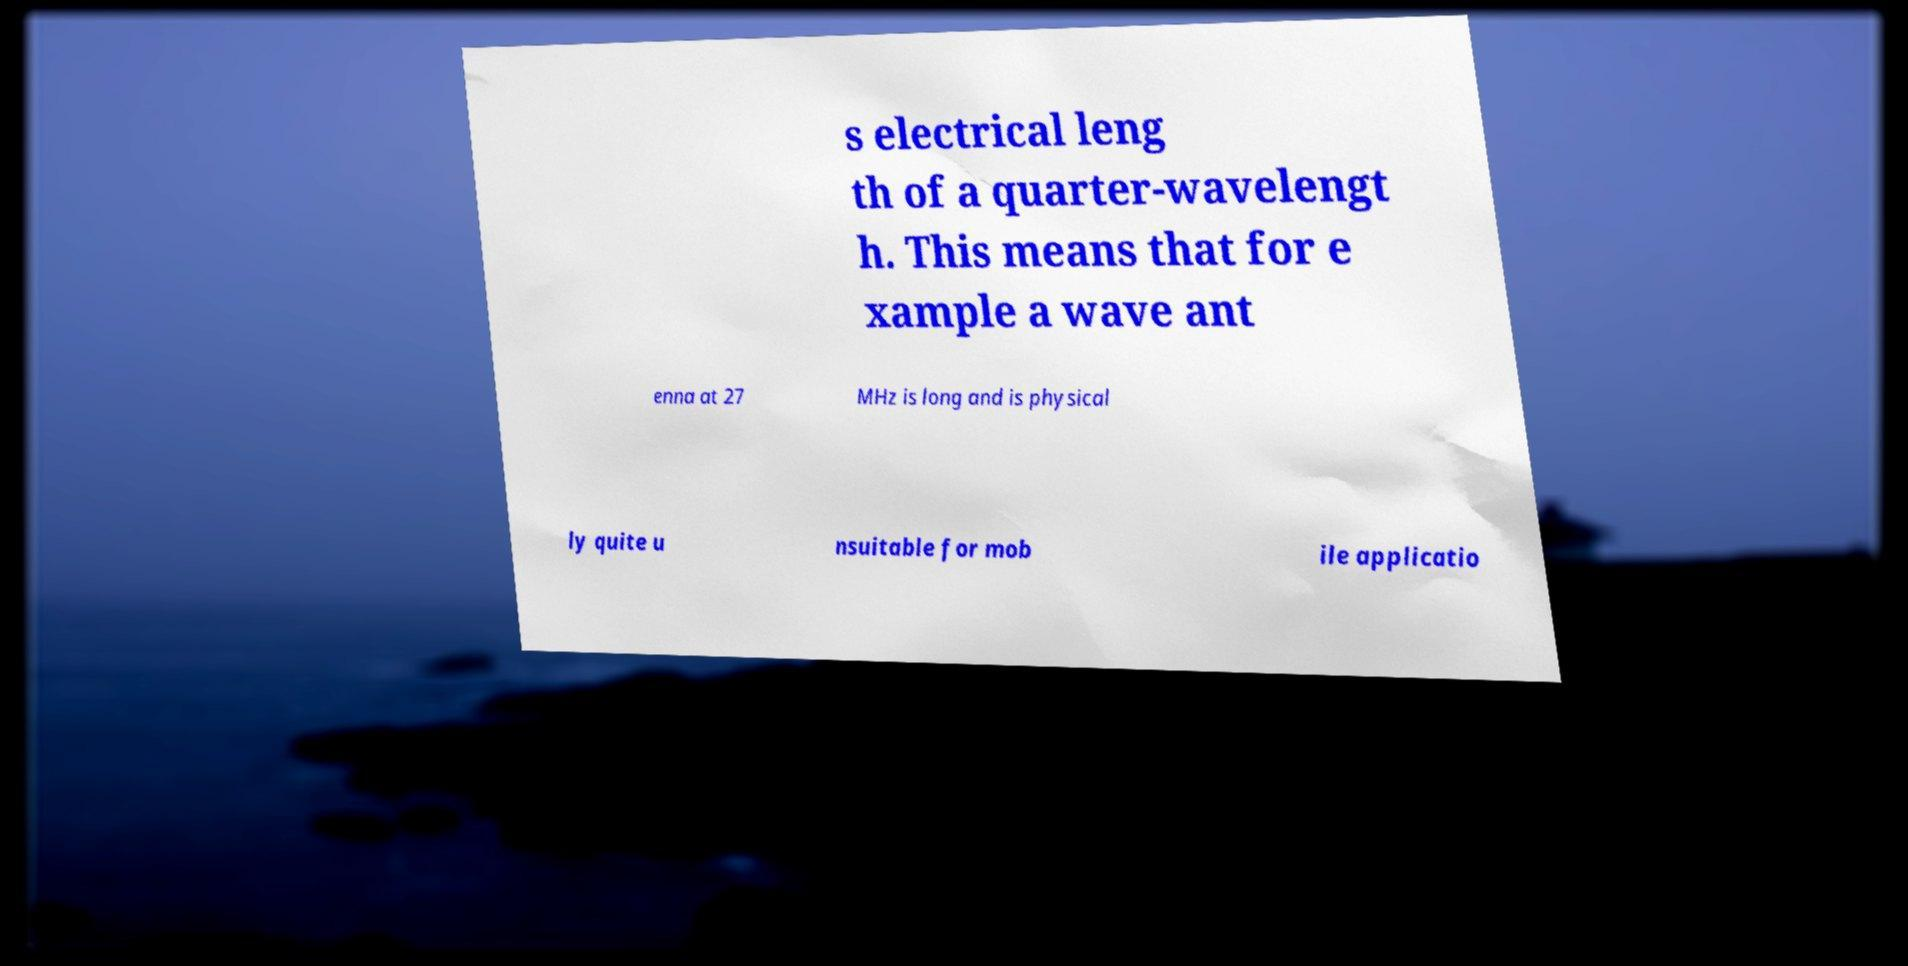Please read and relay the text visible in this image. What does it say? s electrical leng th of a quarter-wavelengt h. This means that for e xample a wave ant enna at 27 MHz is long and is physical ly quite u nsuitable for mob ile applicatio 